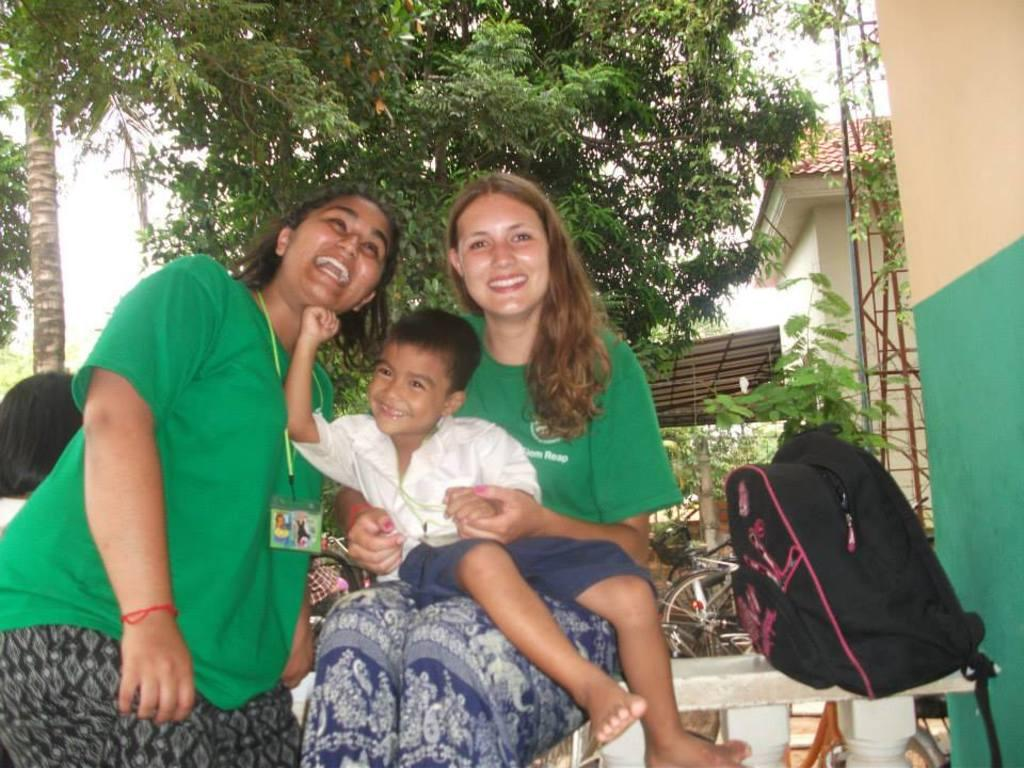What are the women in the image doing? The women are sitting on the wall in the image. Can you describe the interaction between one of the women and a child? One of the women is holding a boy on her lap. What can be seen in the background of the image? There are trees, buildings, a shed, bicycles, and the sky visible in the background of the image. What type of bit is the woman using to control the cherry in the image? There is no bit or cherry present in the image; it features women sitting on a wall and various elements in the background. 